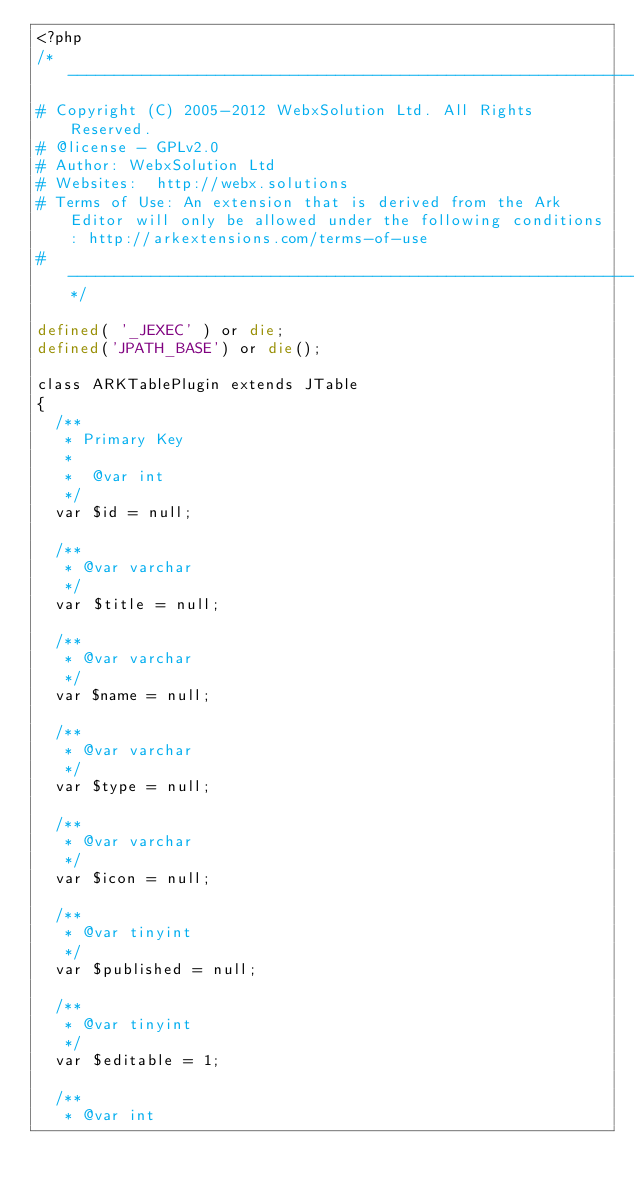<code> <loc_0><loc_0><loc_500><loc_500><_PHP_><?php
/*------------------------------------------------------------------------
# Copyright (C) 2005-2012 WebxSolution Ltd. All Rights Reserved.
# @license - GPLv2.0
# Author: WebxSolution Ltd
# Websites:  http://webx.solutions
# Terms of Use: An extension that is derived from the Ark Editor will only be allowed under the following conditions: http://arkextensions.com/terms-of-use
# ------------------------------------------------------------------------*/ 

defined( '_JEXEC' ) or die;
defined('JPATH_BASE') or die();

class ARKTablePlugin extends JTable
{
	/**
	 * Primary Key
	 *
	 *  @var int
	 */
	var $id = null;

	/**
	 * @var varchar
	 */
	var $title = null;

	/**
	 * @var varchar
	 */
	var $name = null;

	/**
	 * @var varchar
	 */
	var $type = null;
	
	/**
	 * @var varchar
	 */
	var $icon = null;
	
	/**
	 * @var tinyint
	 */
	var $published = null;
	
	/**
	 * @var tinyint
	 */
	var $editable = 1;

	/**
	 * @var int</code> 